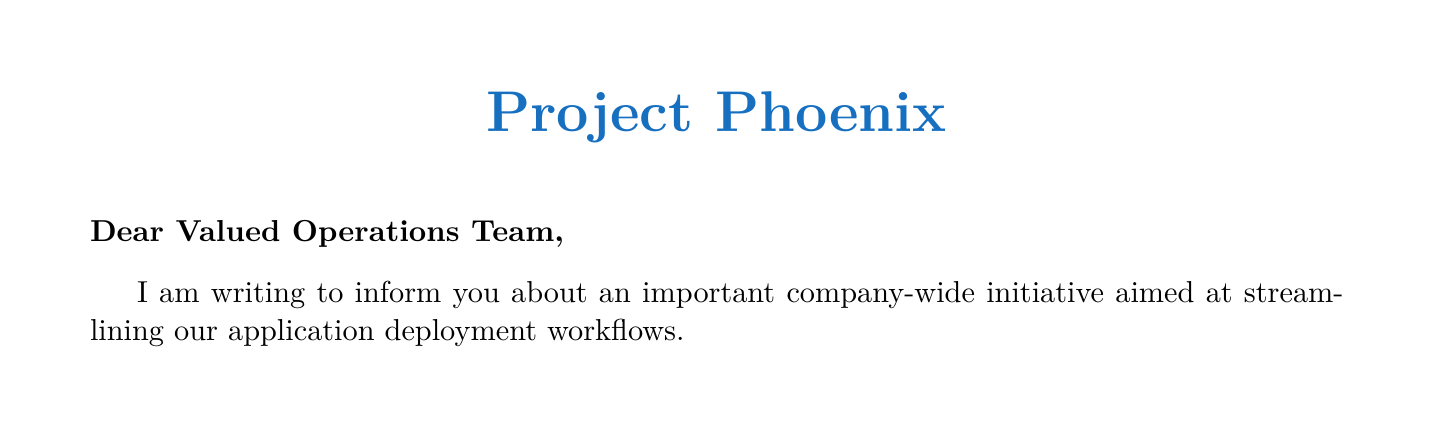What is the name of the initiative? The initiative is referred to as "Project Phoenix" in the document.
Answer: Project Phoenix How long will the Assessment and Planning phase take? The document states that the Assessment and Planning phase will last for 2 months.
Answer: 2 months What is one of the current challenges mentioned? The document lists several challenges, one example is "Inconsistent deployment practices across different teams."
Answer: Inconsistent deployment practices across different teams What is the expected reduction in deployment time? According to the document, the deployment time is expected to reduce from an average of 4 hours to under 30 minutes.
Answer: Under 30 minutes Who is the Chief Technology Officer? The document includes a closing signature without a specific name, but it is the role of the sender.
Answer: [Executive Name] What will be discussed in the kick-off meeting? The kick-off meeting will likely cover the initiation of the Project Phoenix initiative as mentioned in the next steps section.
Answer: Project Phoenix initiative What is the overall goal of Project Phoenix? The goal of Project Phoenix is to streamline application deployment workflows, as stated in the introduction.
Answer: Streamline application deployment workflows Which tool will be implemented for unified pipeline management? The document specifies that GitLab CI/CD will be implemented for unified pipeline management.
Answer: GitLab CI/CD What is the expected decrease in deployment-related incidents? The document mentions an expected decrease of 75% in deployment-related incidents.
Answer: 75% 